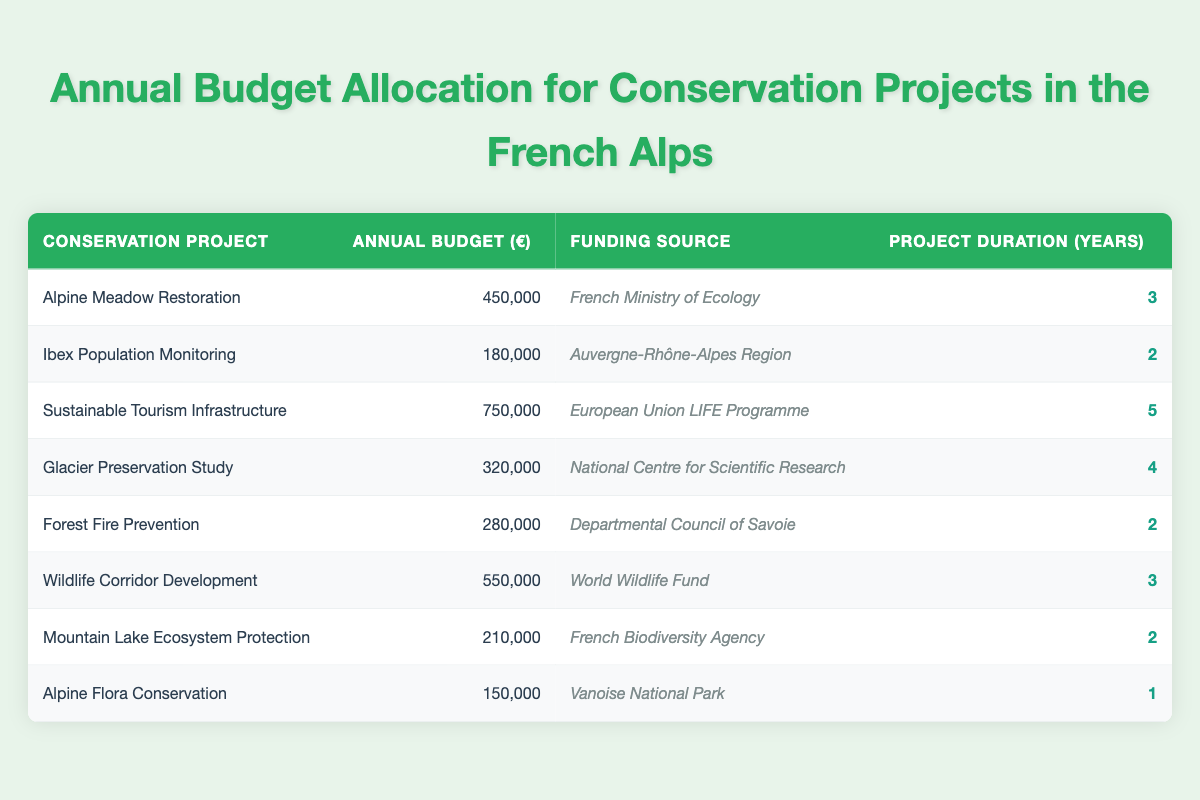What is the budget allocated for the Wildlife Corridor Development project? The budget for the Wildlife Corridor Development project is explicitly listed in the table under the column "Annual Budget (€)", which shows the amount as 550,000.
Answer: 550,000 Which project has the highest annual budget, and what is that amount? The project with the highest annual budget is the Sustainable Tourism Infrastructure project, with an allocated budget of 750,000. This can be found by comparing the values in the "Annual Budget (€)" column.
Answer: Sustainable Tourism Infrastructure, 750,000 What is the total budget allocated to projects financed by the French Ministry of Ecology? To find this, identify the projects funded by the French Ministry of Ecology: there is only one, the Alpine Meadow Restoration, with a budget of 450,000. Therefore, the total budget for this funding source is also 450,000.
Answer: 450,000 Is the duration of the Mountain Lake Ecosystem Protection project greater than one year? The duration for the Mountain Lake Ecosystem Protection project is listed as 2 years in the "Project Duration (Years)" column. Since 2 is greater than 1, the answer is yes.
Answer: Yes What is the average annual budget for projects that have a duration of 3 years? First, identify the projects with a duration of 3 years: Alpine Meadow Restoration (450,000) and Wildlife Corridor Development (550,000). Adding these budgets gives 450,000 + 550,000 = 1,000,000. Then, divide by the number of projects (2) to get the average: 1,000,000 / 2 = 500,000.
Answer: 500,000 How many projects are funded by the World Wildlife Fund? Checking the table, there is one project funded by the World Wildlife Fund, which is the Wildlife Corridor Development project. Therefore, the answer is one.
Answer: One Is the budget for the Ibex Population Monitoring project less than 200,000? The budget for the Ibex Population Monitoring project is listed as 180,000, which is indeed less than 200,000. Thus, the answer is yes.
Answer: Yes What is the total duration of the projects funded by the European Union LIFE Programme? The only project funded by the European Union LIFE Programme is the Sustainable Tourism Infrastructure project, which has a duration of 5 years. Therefore, the total duration is 5.
Answer: 5 